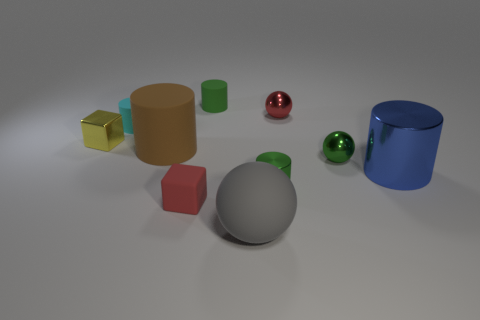There is a shiny cube that is the same size as the green shiny cylinder; what is its color?
Provide a succinct answer. Yellow. What number of other objects are the same shape as the brown thing?
Provide a short and direct response. 4. Does the cyan object have the same size as the green metal ball?
Your response must be concise. Yes. Is the number of red shiny things right of the cyan cylinder greater than the number of tiny matte cylinders that are in front of the blue metal cylinder?
Offer a terse response. Yes. How many other objects are there of the same size as the metallic cube?
Your response must be concise. 6. There is a small cube that is right of the small yellow thing; does it have the same color as the big rubber sphere?
Offer a terse response. No. Is the number of large brown objects that are on the right side of the large shiny cylinder greater than the number of red balls?
Ensure brevity in your answer.  No. Is there anything else that is the same color as the small metallic block?
Your answer should be compact. No. There is a tiny red object left of the tiny green object that is in front of the blue metallic cylinder; what shape is it?
Provide a succinct answer. Cube. Is the number of small metal objects greater than the number of tiny metallic cylinders?
Your answer should be compact. Yes. 